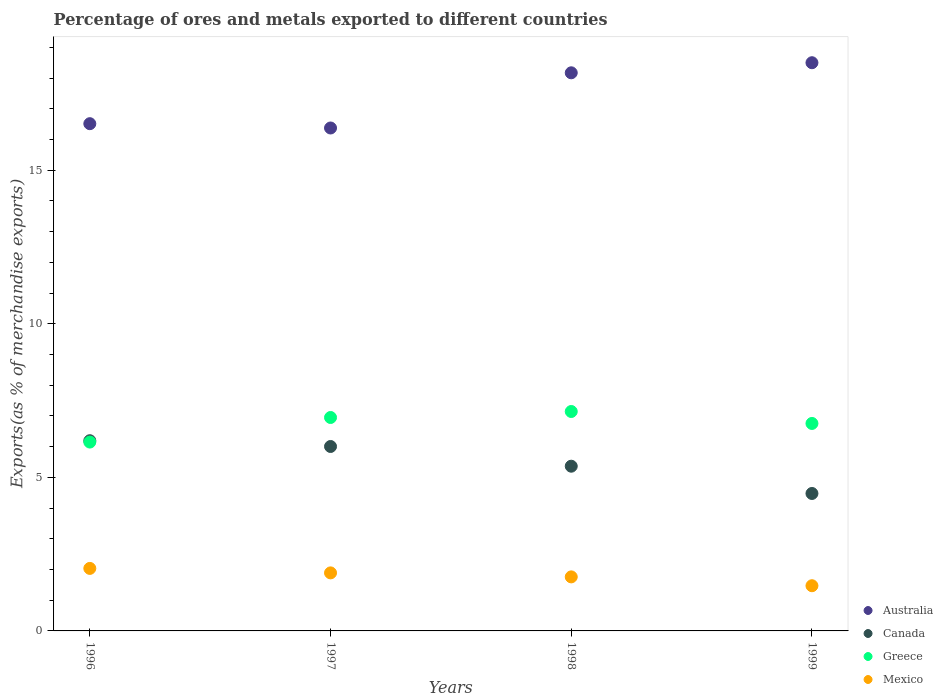How many different coloured dotlines are there?
Ensure brevity in your answer.  4. What is the percentage of exports to different countries in Australia in 1997?
Your answer should be very brief. 16.38. Across all years, what is the maximum percentage of exports to different countries in Australia?
Your answer should be very brief. 18.5. Across all years, what is the minimum percentage of exports to different countries in Australia?
Your answer should be compact. 16.38. In which year was the percentage of exports to different countries in Canada maximum?
Keep it short and to the point. 1996. In which year was the percentage of exports to different countries in Mexico minimum?
Keep it short and to the point. 1999. What is the total percentage of exports to different countries in Canada in the graph?
Provide a succinct answer. 22.04. What is the difference between the percentage of exports to different countries in Australia in 1996 and that in 1999?
Keep it short and to the point. -1.98. What is the difference between the percentage of exports to different countries in Canada in 1998 and the percentage of exports to different countries in Mexico in 1996?
Offer a very short reply. 3.33. What is the average percentage of exports to different countries in Canada per year?
Offer a terse response. 5.51. In the year 1996, what is the difference between the percentage of exports to different countries in Greece and percentage of exports to different countries in Canada?
Ensure brevity in your answer.  -0.04. What is the ratio of the percentage of exports to different countries in Australia in 1998 to that in 1999?
Offer a very short reply. 0.98. Is the difference between the percentage of exports to different countries in Greece in 1996 and 1998 greater than the difference between the percentage of exports to different countries in Canada in 1996 and 1998?
Offer a very short reply. No. What is the difference between the highest and the second highest percentage of exports to different countries in Greece?
Provide a short and direct response. 0.2. What is the difference between the highest and the lowest percentage of exports to different countries in Mexico?
Your answer should be compact. 0.56. In how many years, is the percentage of exports to different countries in Greece greater than the average percentage of exports to different countries in Greece taken over all years?
Provide a succinct answer. 3. Is it the case that in every year, the sum of the percentage of exports to different countries in Canada and percentage of exports to different countries in Mexico  is greater than the sum of percentage of exports to different countries in Greece and percentage of exports to different countries in Australia?
Offer a terse response. No. Is it the case that in every year, the sum of the percentage of exports to different countries in Greece and percentage of exports to different countries in Mexico  is greater than the percentage of exports to different countries in Canada?
Your answer should be very brief. Yes. Does the percentage of exports to different countries in Greece monotonically increase over the years?
Your answer should be very brief. No. Is the percentage of exports to different countries in Mexico strictly less than the percentage of exports to different countries in Greece over the years?
Give a very brief answer. Yes. How many years are there in the graph?
Your response must be concise. 4. What is the difference between two consecutive major ticks on the Y-axis?
Your answer should be very brief. 5. Are the values on the major ticks of Y-axis written in scientific E-notation?
Your response must be concise. No. Does the graph contain grids?
Keep it short and to the point. No. How many legend labels are there?
Your response must be concise. 4. How are the legend labels stacked?
Make the answer very short. Vertical. What is the title of the graph?
Provide a short and direct response. Percentage of ores and metals exported to different countries. What is the label or title of the X-axis?
Offer a very short reply. Years. What is the label or title of the Y-axis?
Provide a short and direct response. Exports(as % of merchandise exports). What is the Exports(as % of merchandise exports) of Australia in 1996?
Your response must be concise. 16.52. What is the Exports(as % of merchandise exports) of Canada in 1996?
Your answer should be very brief. 6.19. What is the Exports(as % of merchandise exports) of Greece in 1996?
Your response must be concise. 6.15. What is the Exports(as % of merchandise exports) of Mexico in 1996?
Offer a very short reply. 2.04. What is the Exports(as % of merchandise exports) in Australia in 1997?
Your answer should be compact. 16.38. What is the Exports(as % of merchandise exports) in Canada in 1997?
Your answer should be compact. 6.01. What is the Exports(as % of merchandise exports) in Greece in 1997?
Provide a short and direct response. 6.95. What is the Exports(as % of merchandise exports) in Mexico in 1997?
Give a very brief answer. 1.89. What is the Exports(as % of merchandise exports) in Australia in 1998?
Offer a very short reply. 18.17. What is the Exports(as % of merchandise exports) in Canada in 1998?
Offer a very short reply. 5.36. What is the Exports(as % of merchandise exports) of Greece in 1998?
Offer a terse response. 7.14. What is the Exports(as % of merchandise exports) of Mexico in 1998?
Provide a short and direct response. 1.76. What is the Exports(as % of merchandise exports) of Australia in 1999?
Make the answer very short. 18.5. What is the Exports(as % of merchandise exports) of Canada in 1999?
Offer a very short reply. 4.48. What is the Exports(as % of merchandise exports) of Greece in 1999?
Provide a succinct answer. 6.76. What is the Exports(as % of merchandise exports) in Mexico in 1999?
Offer a very short reply. 1.47. Across all years, what is the maximum Exports(as % of merchandise exports) in Australia?
Provide a succinct answer. 18.5. Across all years, what is the maximum Exports(as % of merchandise exports) in Canada?
Your answer should be compact. 6.19. Across all years, what is the maximum Exports(as % of merchandise exports) of Greece?
Offer a very short reply. 7.14. Across all years, what is the maximum Exports(as % of merchandise exports) in Mexico?
Your response must be concise. 2.04. Across all years, what is the minimum Exports(as % of merchandise exports) of Australia?
Offer a terse response. 16.38. Across all years, what is the minimum Exports(as % of merchandise exports) of Canada?
Provide a short and direct response. 4.48. Across all years, what is the minimum Exports(as % of merchandise exports) in Greece?
Give a very brief answer. 6.15. Across all years, what is the minimum Exports(as % of merchandise exports) in Mexico?
Provide a succinct answer. 1.47. What is the total Exports(as % of merchandise exports) of Australia in the graph?
Provide a succinct answer. 69.57. What is the total Exports(as % of merchandise exports) in Canada in the graph?
Make the answer very short. 22.04. What is the total Exports(as % of merchandise exports) in Greece in the graph?
Provide a succinct answer. 27. What is the total Exports(as % of merchandise exports) of Mexico in the graph?
Your answer should be very brief. 7.16. What is the difference between the Exports(as % of merchandise exports) of Australia in 1996 and that in 1997?
Your answer should be very brief. 0.14. What is the difference between the Exports(as % of merchandise exports) in Canada in 1996 and that in 1997?
Give a very brief answer. 0.19. What is the difference between the Exports(as % of merchandise exports) of Greece in 1996 and that in 1997?
Offer a terse response. -0.8. What is the difference between the Exports(as % of merchandise exports) of Mexico in 1996 and that in 1997?
Offer a very short reply. 0.15. What is the difference between the Exports(as % of merchandise exports) of Australia in 1996 and that in 1998?
Offer a very short reply. -1.66. What is the difference between the Exports(as % of merchandise exports) of Canada in 1996 and that in 1998?
Your response must be concise. 0.83. What is the difference between the Exports(as % of merchandise exports) in Greece in 1996 and that in 1998?
Your response must be concise. -1. What is the difference between the Exports(as % of merchandise exports) in Mexico in 1996 and that in 1998?
Give a very brief answer. 0.28. What is the difference between the Exports(as % of merchandise exports) of Australia in 1996 and that in 1999?
Your answer should be very brief. -1.98. What is the difference between the Exports(as % of merchandise exports) of Canada in 1996 and that in 1999?
Provide a succinct answer. 1.72. What is the difference between the Exports(as % of merchandise exports) of Greece in 1996 and that in 1999?
Make the answer very short. -0.61. What is the difference between the Exports(as % of merchandise exports) in Mexico in 1996 and that in 1999?
Keep it short and to the point. 0.56. What is the difference between the Exports(as % of merchandise exports) of Australia in 1997 and that in 1998?
Provide a short and direct response. -1.8. What is the difference between the Exports(as % of merchandise exports) in Canada in 1997 and that in 1998?
Give a very brief answer. 0.64. What is the difference between the Exports(as % of merchandise exports) in Greece in 1997 and that in 1998?
Ensure brevity in your answer.  -0.2. What is the difference between the Exports(as % of merchandise exports) in Mexico in 1997 and that in 1998?
Offer a terse response. 0.13. What is the difference between the Exports(as % of merchandise exports) of Australia in 1997 and that in 1999?
Provide a succinct answer. -2.13. What is the difference between the Exports(as % of merchandise exports) in Canada in 1997 and that in 1999?
Give a very brief answer. 1.53. What is the difference between the Exports(as % of merchandise exports) of Greece in 1997 and that in 1999?
Give a very brief answer. 0.19. What is the difference between the Exports(as % of merchandise exports) of Mexico in 1997 and that in 1999?
Provide a succinct answer. 0.42. What is the difference between the Exports(as % of merchandise exports) in Australia in 1998 and that in 1999?
Provide a short and direct response. -0.33. What is the difference between the Exports(as % of merchandise exports) of Canada in 1998 and that in 1999?
Make the answer very short. 0.89. What is the difference between the Exports(as % of merchandise exports) of Greece in 1998 and that in 1999?
Provide a succinct answer. 0.39. What is the difference between the Exports(as % of merchandise exports) in Mexico in 1998 and that in 1999?
Your answer should be very brief. 0.29. What is the difference between the Exports(as % of merchandise exports) in Australia in 1996 and the Exports(as % of merchandise exports) in Canada in 1997?
Keep it short and to the point. 10.51. What is the difference between the Exports(as % of merchandise exports) of Australia in 1996 and the Exports(as % of merchandise exports) of Greece in 1997?
Give a very brief answer. 9.57. What is the difference between the Exports(as % of merchandise exports) of Australia in 1996 and the Exports(as % of merchandise exports) of Mexico in 1997?
Provide a succinct answer. 14.63. What is the difference between the Exports(as % of merchandise exports) of Canada in 1996 and the Exports(as % of merchandise exports) of Greece in 1997?
Provide a succinct answer. -0.76. What is the difference between the Exports(as % of merchandise exports) in Canada in 1996 and the Exports(as % of merchandise exports) in Mexico in 1997?
Provide a short and direct response. 4.3. What is the difference between the Exports(as % of merchandise exports) of Greece in 1996 and the Exports(as % of merchandise exports) of Mexico in 1997?
Your answer should be compact. 4.26. What is the difference between the Exports(as % of merchandise exports) in Australia in 1996 and the Exports(as % of merchandise exports) in Canada in 1998?
Keep it short and to the point. 11.15. What is the difference between the Exports(as % of merchandise exports) in Australia in 1996 and the Exports(as % of merchandise exports) in Greece in 1998?
Give a very brief answer. 9.37. What is the difference between the Exports(as % of merchandise exports) in Australia in 1996 and the Exports(as % of merchandise exports) in Mexico in 1998?
Offer a very short reply. 14.76. What is the difference between the Exports(as % of merchandise exports) of Canada in 1996 and the Exports(as % of merchandise exports) of Greece in 1998?
Make the answer very short. -0.95. What is the difference between the Exports(as % of merchandise exports) in Canada in 1996 and the Exports(as % of merchandise exports) in Mexico in 1998?
Ensure brevity in your answer.  4.43. What is the difference between the Exports(as % of merchandise exports) of Greece in 1996 and the Exports(as % of merchandise exports) of Mexico in 1998?
Offer a terse response. 4.39. What is the difference between the Exports(as % of merchandise exports) in Australia in 1996 and the Exports(as % of merchandise exports) in Canada in 1999?
Ensure brevity in your answer.  12.04. What is the difference between the Exports(as % of merchandise exports) of Australia in 1996 and the Exports(as % of merchandise exports) of Greece in 1999?
Your response must be concise. 9.76. What is the difference between the Exports(as % of merchandise exports) of Australia in 1996 and the Exports(as % of merchandise exports) of Mexico in 1999?
Your answer should be very brief. 15.05. What is the difference between the Exports(as % of merchandise exports) in Canada in 1996 and the Exports(as % of merchandise exports) in Greece in 1999?
Your answer should be very brief. -0.56. What is the difference between the Exports(as % of merchandise exports) of Canada in 1996 and the Exports(as % of merchandise exports) of Mexico in 1999?
Ensure brevity in your answer.  4.72. What is the difference between the Exports(as % of merchandise exports) of Greece in 1996 and the Exports(as % of merchandise exports) of Mexico in 1999?
Offer a very short reply. 4.68. What is the difference between the Exports(as % of merchandise exports) in Australia in 1997 and the Exports(as % of merchandise exports) in Canada in 1998?
Your answer should be compact. 11.01. What is the difference between the Exports(as % of merchandise exports) of Australia in 1997 and the Exports(as % of merchandise exports) of Greece in 1998?
Ensure brevity in your answer.  9.23. What is the difference between the Exports(as % of merchandise exports) in Australia in 1997 and the Exports(as % of merchandise exports) in Mexico in 1998?
Provide a short and direct response. 14.62. What is the difference between the Exports(as % of merchandise exports) of Canada in 1997 and the Exports(as % of merchandise exports) of Greece in 1998?
Your answer should be compact. -1.14. What is the difference between the Exports(as % of merchandise exports) of Canada in 1997 and the Exports(as % of merchandise exports) of Mexico in 1998?
Your response must be concise. 4.25. What is the difference between the Exports(as % of merchandise exports) of Greece in 1997 and the Exports(as % of merchandise exports) of Mexico in 1998?
Give a very brief answer. 5.19. What is the difference between the Exports(as % of merchandise exports) of Australia in 1997 and the Exports(as % of merchandise exports) of Canada in 1999?
Offer a terse response. 11.9. What is the difference between the Exports(as % of merchandise exports) in Australia in 1997 and the Exports(as % of merchandise exports) in Greece in 1999?
Provide a succinct answer. 9.62. What is the difference between the Exports(as % of merchandise exports) in Australia in 1997 and the Exports(as % of merchandise exports) in Mexico in 1999?
Offer a terse response. 14.9. What is the difference between the Exports(as % of merchandise exports) in Canada in 1997 and the Exports(as % of merchandise exports) in Greece in 1999?
Give a very brief answer. -0.75. What is the difference between the Exports(as % of merchandise exports) in Canada in 1997 and the Exports(as % of merchandise exports) in Mexico in 1999?
Ensure brevity in your answer.  4.53. What is the difference between the Exports(as % of merchandise exports) of Greece in 1997 and the Exports(as % of merchandise exports) of Mexico in 1999?
Keep it short and to the point. 5.48. What is the difference between the Exports(as % of merchandise exports) in Australia in 1998 and the Exports(as % of merchandise exports) in Canada in 1999?
Give a very brief answer. 13.7. What is the difference between the Exports(as % of merchandise exports) of Australia in 1998 and the Exports(as % of merchandise exports) of Greece in 1999?
Ensure brevity in your answer.  11.42. What is the difference between the Exports(as % of merchandise exports) of Australia in 1998 and the Exports(as % of merchandise exports) of Mexico in 1999?
Provide a succinct answer. 16.7. What is the difference between the Exports(as % of merchandise exports) of Canada in 1998 and the Exports(as % of merchandise exports) of Greece in 1999?
Offer a terse response. -1.39. What is the difference between the Exports(as % of merchandise exports) of Canada in 1998 and the Exports(as % of merchandise exports) of Mexico in 1999?
Offer a very short reply. 3.89. What is the difference between the Exports(as % of merchandise exports) of Greece in 1998 and the Exports(as % of merchandise exports) of Mexico in 1999?
Make the answer very short. 5.67. What is the average Exports(as % of merchandise exports) in Australia per year?
Offer a terse response. 17.39. What is the average Exports(as % of merchandise exports) of Canada per year?
Give a very brief answer. 5.51. What is the average Exports(as % of merchandise exports) in Greece per year?
Your answer should be compact. 6.75. What is the average Exports(as % of merchandise exports) of Mexico per year?
Your answer should be compact. 1.79. In the year 1996, what is the difference between the Exports(as % of merchandise exports) in Australia and Exports(as % of merchandise exports) in Canada?
Your answer should be compact. 10.32. In the year 1996, what is the difference between the Exports(as % of merchandise exports) of Australia and Exports(as % of merchandise exports) of Greece?
Your answer should be compact. 10.37. In the year 1996, what is the difference between the Exports(as % of merchandise exports) of Australia and Exports(as % of merchandise exports) of Mexico?
Ensure brevity in your answer.  14.48. In the year 1996, what is the difference between the Exports(as % of merchandise exports) in Canada and Exports(as % of merchandise exports) in Greece?
Provide a short and direct response. 0.04. In the year 1996, what is the difference between the Exports(as % of merchandise exports) of Canada and Exports(as % of merchandise exports) of Mexico?
Your answer should be compact. 4.16. In the year 1996, what is the difference between the Exports(as % of merchandise exports) in Greece and Exports(as % of merchandise exports) in Mexico?
Offer a terse response. 4.11. In the year 1997, what is the difference between the Exports(as % of merchandise exports) in Australia and Exports(as % of merchandise exports) in Canada?
Offer a very short reply. 10.37. In the year 1997, what is the difference between the Exports(as % of merchandise exports) in Australia and Exports(as % of merchandise exports) in Greece?
Make the answer very short. 9.43. In the year 1997, what is the difference between the Exports(as % of merchandise exports) of Australia and Exports(as % of merchandise exports) of Mexico?
Your answer should be very brief. 14.49. In the year 1997, what is the difference between the Exports(as % of merchandise exports) of Canada and Exports(as % of merchandise exports) of Greece?
Your answer should be compact. -0.94. In the year 1997, what is the difference between the Exports(as % of merchandise exports) in Canada and Exports(as % of merchandise exports) in Mexico?
Your answer should be very brief. 4.12. In the year 1997, what is the difference between the Exports(as % of merchandise exports) of Greece and Exports(as % of merchandise exports) of Mexico?
Provide a succinct answer. 5.06. In the year 1998, what is the difference between the Exports(as % of merchandise exports) in Australia and Exports(as % of merchandise exports) in Canada?
Keep it short and to the point. 12.81. In the year 1998, what is the difference between the Exports(as % of merchandise exports) in Australia and Exports(as % of merchandise exports) in Greece?
Make the answer very short. 11.03. In the year 1998, what is the difference between the Exports(as % of merchandise exports) of Australia and Exports(as % of merchandise exports) of Mexico?
Offer a very short reply. 16.41. In the year 1998, what is the difference between the Exports(as % of merchandise exports) in Canada and Exports(as % of merchandise exports) in Greece?
Your answer should be very brief. -1.78. In the year 1998, what is the difference between the Exports(as % of merchandise exports) in Canada and Exports(as % of merchandise exports) in Mexico?
Your answer should be compact. 3.6. In the year 1998, what is the difference between the Exports(as % of merchandise exports) in Greece and Exports(as % of merchandise exports) in Mexico?
Offer a very short reply. 5.39. In the year 1999, what is the difference between the Exports(as % of merchandise exports) in Australia and Exports(as % of merchandise exports) in Canada?
Keep it short and to the point. 14.03. In the year 1999, what is the difference between the Exports(as % of merchandise exports) of Australia and Exports(as % of merchandise exports) of Greece?
Keep it short and to the point. 11.75. In the year 1999, what is the difference between the Exports(as % of merchandise exports) of Australia and Exports(as % of merchandise exports) of Mexico?
Provide a short and direct response. 17.03. In the year 1999, what is the difference between the Exports(as % of merchandise exports) in Canada and Exports(as % of merchandise exports) in Greece?
Your answer should be compact. -2.28. In the year 1999, what is the difference between the Exports(as % of merchandise exports) of Canada and Exports(as % of merchandise exports) of Mexico?
Ensure brevity in your answer.  3. In the year 1999, what is the difference between the Exports(as % of merchandise exports) of Greece and Exports(as % of merchandise exports) of Mexico?
Give a very brief answer. 5.28. What is the ratio of the Exports(as % of merchandise exports) in Australia in 1996 to that in 1997?
Give a very brief answer. 1.01. What is the ratio of the Exports(as % of merchandise exports) in Canada in 1996 to that in 1997?
Provide a succinct answer. 1.03. What is the ratio of the Exports(as % of merchandise exports) in Greece in 1996 to that in 1997?
Provide a succinct answer. 0.88. What is the ratio of the Exports(as % of merchandise exports) in Mexico in 1996 to that in 1997?
Your response must be concise. 1.08. What is the ratio of the Exports(as % of merchandise exports) of Australia in 1996 to that in 1998?
Provide a short and direct response. 0.91. What is the ratio of the Exports(as % of merchandise exports) of Canada in 1996 to that in 1998?
Keep it short and to the point. 1.15. What is the ratio of the Exports(as % of merchandise exports) of Greece in 1996 to that in 1998?
Make the answer very short. 0.86. What is the ratio of the Exports(as % of merchandise exports) in Mexico in 1996 to that in 1998?
Provide a short and direct response. 1.16. What is the ratio of the Exports(as % of merchandise exports) of Australia in 1996 to that in 1999?
Provide a succinct answer. 0.89. What is the ratio of the Exports(as % of merchandise exports) in Canada in 1996 to that in 1999?
Your response must be concise. 1.38. What is the ratio of the Exports(as % of merchandise exports) in Greece in 1996 to that in 1999?
Your answer should be compact. 0.91. What is the ratio of the Exports(as % of merchandise exports) in Mexico in 1996 to that in 1999?
Provide a succinct answer. 1.38. What is the ratio of the Exports(as % of merchandise exports) in Australia in 1997 to that in 1998?
Your response must be concise. 0.9. What is the ratio of the Exports(as % of merchandise exports) in Canada in 1997 to that in 1998?
Your response must be concise. 1.12. What is the ratio of the Exports(as % of merchandise exports) of Greece in 1997 to that in 1998?
Your answer should be compact. 0.97. What is the ratio of the Exports(as % of merchandise exports) of Mexico in 1997 to that in 1998?
Give a very brief answer. 1.07. What is the ratio of the Exports(as % of merchandise exports) in Australia in 1997 to that in 1999?
Offer a terse response. 0.89. What is the ratio of the Exports(as % of merchandise exports) in Canada in 1997 to that in 1999?
Ensure brevity in your answer.  1.34. What is the ratio of the Exports(as % of merchandise exports) in Greece in 1997 to that in 1999?
Your answer should be compact. 1.03. What is the ratio of the Exports(as % of merchandise exports) of Mexico in 1997 to that in 1999?
Provide a short and direct response. 1.28. What is the ratio of the Exports(as % of merchandise exports) in Australia in 1998 to that in 1999?
Offer a very short reply. 0.98. What is the ratio of the Exports(as % of merchandise exports) of Canada in 1998 to that in 1999?
Make the answer very short. 1.2. What is the ratio of the Exports(as % of merchandise exports) of Greece in 1998 to that in 1999?
Your answer should be compact. 1.06. What is the ratio of the Exports(as % of merchandise exports) in Mexico in 1998 to that in 1999?
Provide a short and direct response. 1.2. What is the difference between the highest and the second highest Exports(as % of merchandise exports) in Australia?
Provide a short and direct response. 0.33. What is the difference between the highest and the second highest Exports(as % of merchandise exports) in Canada?
Make the answer very short. 0.19. What is the difference between the highest and the second highest Exports(as % of merchandise exports) in Greece?
Offer a very short reply. 0.2. What is the difference between the highest and the second highest Exports(as % of merchandise exports) in Mexico?
Make the answer very short. 0.15. What is the difference between the highest and the lowest Exports(as % of merchandise exports) in Australia?
Your answer should be compact. 2.13. What is the difference between the highest and the lowest Exports(as % of merchandise exports) in Canada?
Your response must be concise. 1.72. What is the difference between the highest and the lowest Exports(as % of merchandise exports) in Mexico?
Provide a short and direct response. 0.56. 